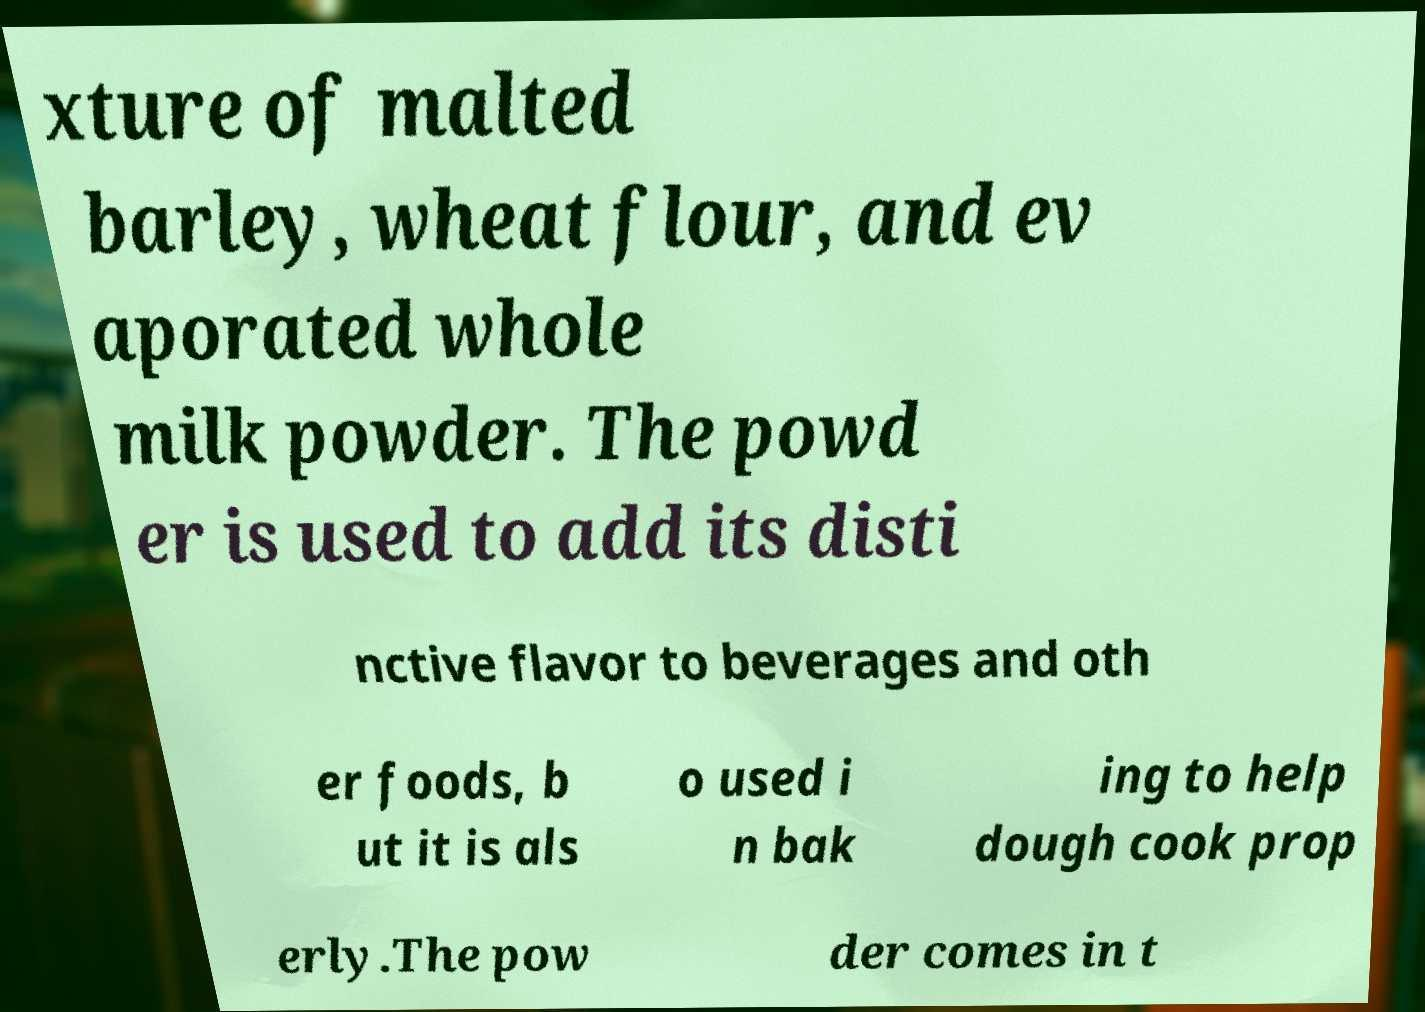Please identify and transcribe the text found in this image. xture of malted barley, wheat flour, and ev aporated whole milk powder. The powd er is used to add its disti nctive flavor to beverages and oth er foods, b ut it is als o used i n bak ing to help dough cook prop erly.The pow der comes in t 